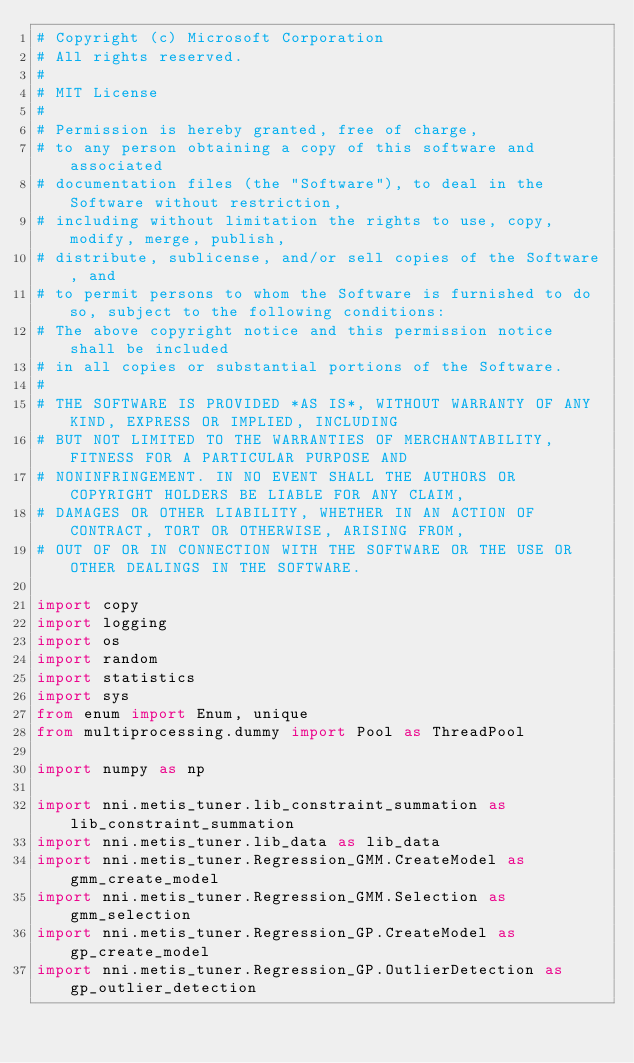<code> <loc_0><loc_0><loc_500><loc_500><_Python_># Copyright (c) Microsoft Corporation
# All rights reserved.
#
# MIT License
#
# Permission is hereby granted, free of charge,
# to any person obtaining a copy of this software and associated
# documentation files (the "Software"), to deal in the Software without restriction,
# including without limitation the rights to use, copy, modify, merge, publish,
# distribute, sublicense, and/or sell copies of the Software, and
# to permit persons to whom the Software is furnished to do so, subject to the following conditions:
# The above copyright notice and this permission notice shall be included
# in all copies or substantial portions of the Software.
#
# THE SOFTWARE IS PROVIDED *AS IS*, WITHOUT WARRANTY OF ANY KIND, EXPRESS OR IMPLIED, INCLUDING
# BUT NOT LIMITED TO THE WARRANTIES OF MERCHANTABILITY, FITNESS FOR A PARTICULAR PURPOSE AND
# NONINFRINGEMENT. IN NO EVENT SHALL THE AUTHORS OR COPYRIGHT HOLDERS BE LIABLE FOR ANY CLAIM,
# DAMAGES OR OTHER LIABILITY, WHETHER IN AN ACTION OF CONTRACT, TORT OR OTHERWISE, ARISING FROM,
# OUT OF OR IN CONNECTION WITH THE SOFTWARE OR THE USE OR OTHER DEALINGS IN THE SOFTWARE.

import copy
import logging
import os
import random
import statistics
import sys
from enum import Enum, unique
from multiprocessing.dummy import Pool as ThreadPool

import numpy as np

import nni.metis_tuner.lib_constraint_summation as lib_constraint_summation
import nni.metis_tuner.lib_data as lib_data
import nni.metis_tuner.Regression_GMM.CreateModel as gmm_create_model
import nni.metis_tuner.Regression_GMM.Selection as gmm_selection
import nni.metis_tuner.Regression_GP.CreateModel as gp_create_model
import nni.metis_tuner.Regression_GP.OutlierDetection as gp_outlier_detection</code> 